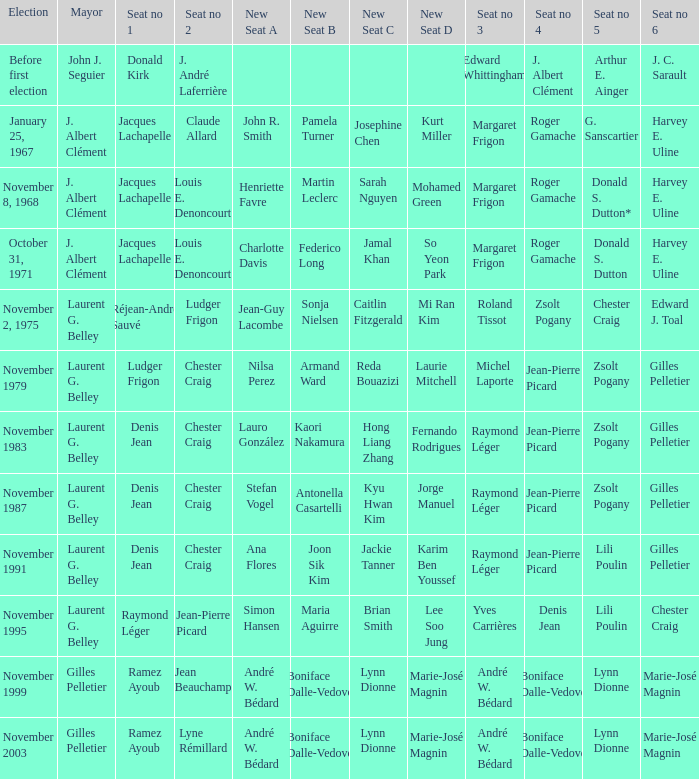Who was the winner of seat no 4 for the election on January 25, 1967 Roger Gamache. 